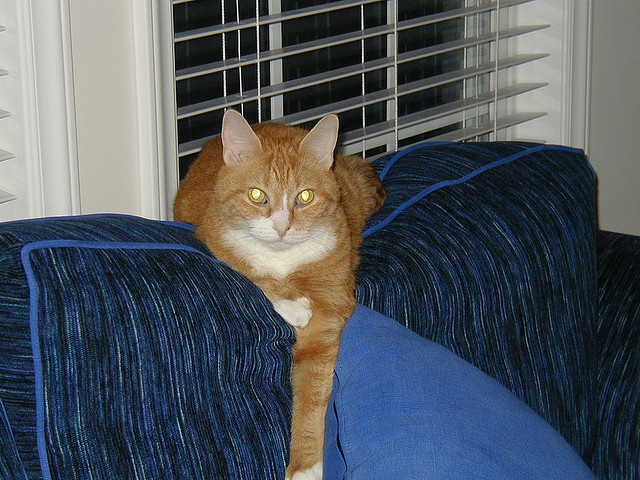Describe the objects in this image and their specific colors. I can see couch in lightgray, black, navy, blue, and darkblue tones and cat in lightgray, tan, olive, and maroon tones in this image. 